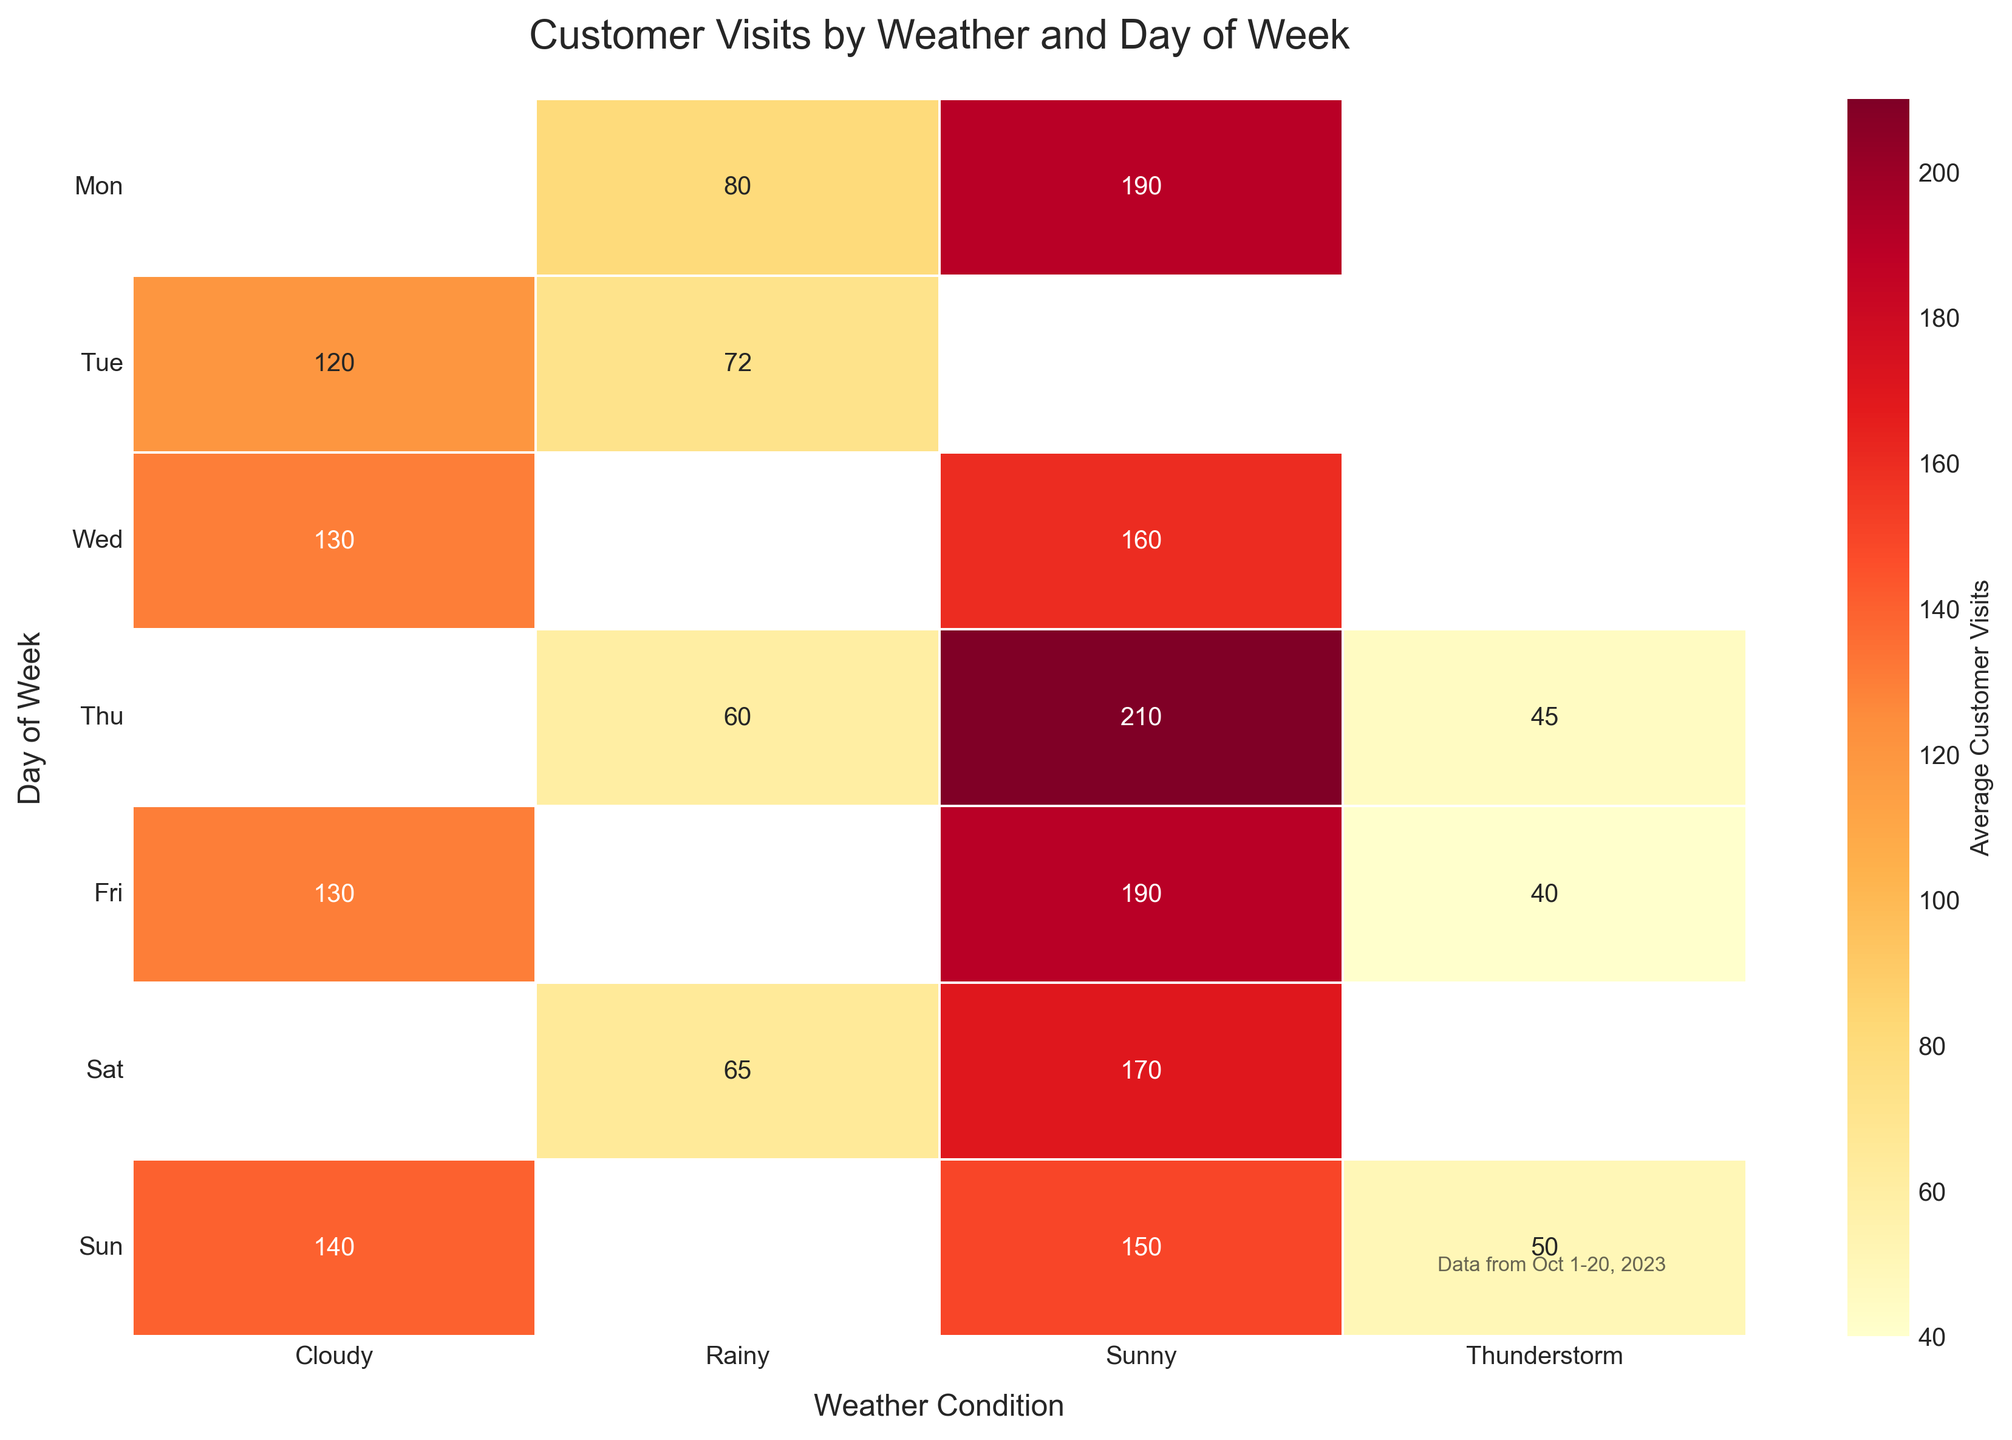Which weather condition leads to the highest average customer visits? The figure shows different average customer visits for various weather conditions. Look at the column with the highest numbers.
Answer: Sunny What is the least busy day of the week on average? Observe the rows and identify the day (row number) with the lowest average customer visits. Then match this row number to the weekday label.
Answer: Monday How does the average number of visits on rainy days compare to sunny days? Compare the average values in the 'Rainy' column with those in the 'Sunny' column.
Answer: Lower on rainy days Which day of the week shows the highest visits on sunny days? Look for the highest value in the 'Sunny' column and note the corresponding day of the week.
Answer: Sunday What is the average customer visit difference between cloudy and thunderstorm days? Take the average of the values in the 'Cloudy' column, do the same for the 'Thunderstorm' column, then subtract the latter from the former.
Answer: Higher on cloudy days Which weather condition shows the most variation in customer visits by day of the week? Identify the column with the most spread-out values (largest difference between maximum and minimum).
Answer: Thunderstorm Are weekends busier than weekdays for any specific weather condition? Compare the values for Friday, Saturday, and Sunday to Monday through Thursday for each weather condition.
Answer: Yes, especially for sunny weather What is the overall trend for customer visits during thunderstorms? Look at the values across all days under 'Thunderstorm' and determine if they are generally low, high, or fluctuating.
Answer: Generally low 